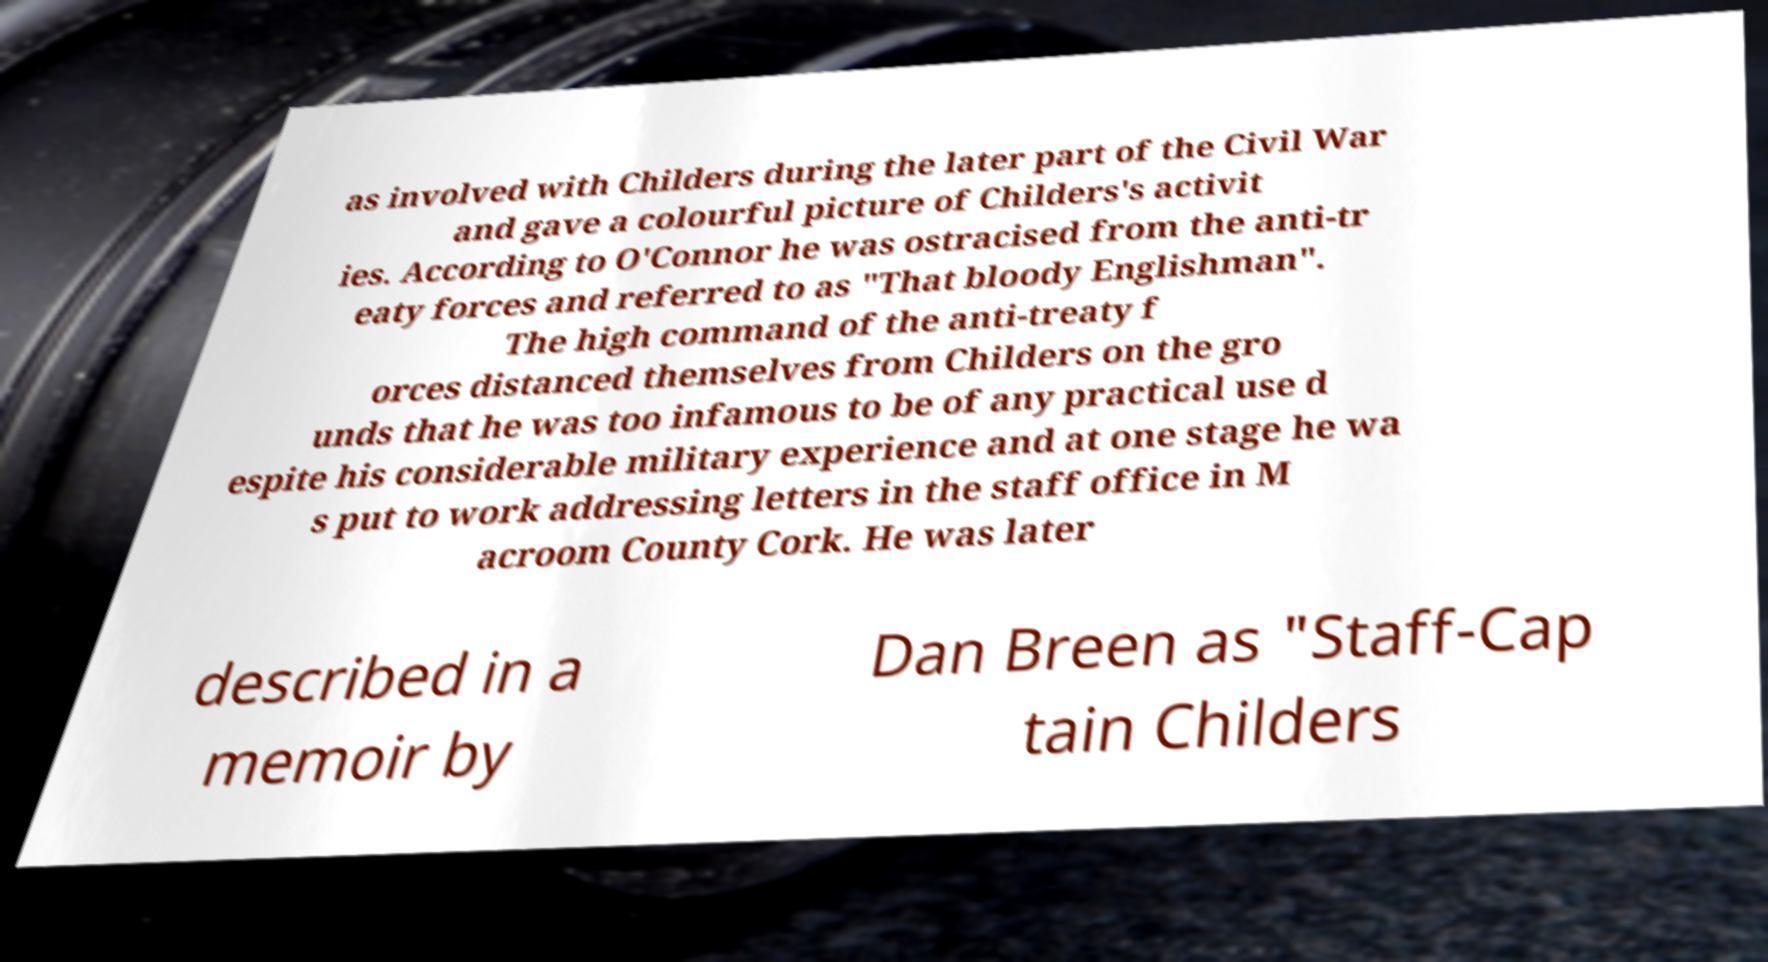Can you read and provide the text displayed in the image?This photo seems to have some interesting text. Can you extract and type it out for me? as involved with Childers during the later part of the Civil War and gave a colourful picture of Childers's activit ies. According to O'Connor he was ostracised from the anti-tr eaty forces and referred to as "That bloody Englishman". The high command of the anti-treaty f orces distanced themselves from Childers on the gro unds that he was too infamous to be of any practical use d espite his considerable military experience and at one stage he wa s put to work addressing letters in the staff office in M acroom County Cork. He was later described in a memoir by Dan Breen as "Staff-Cap tain Childers 